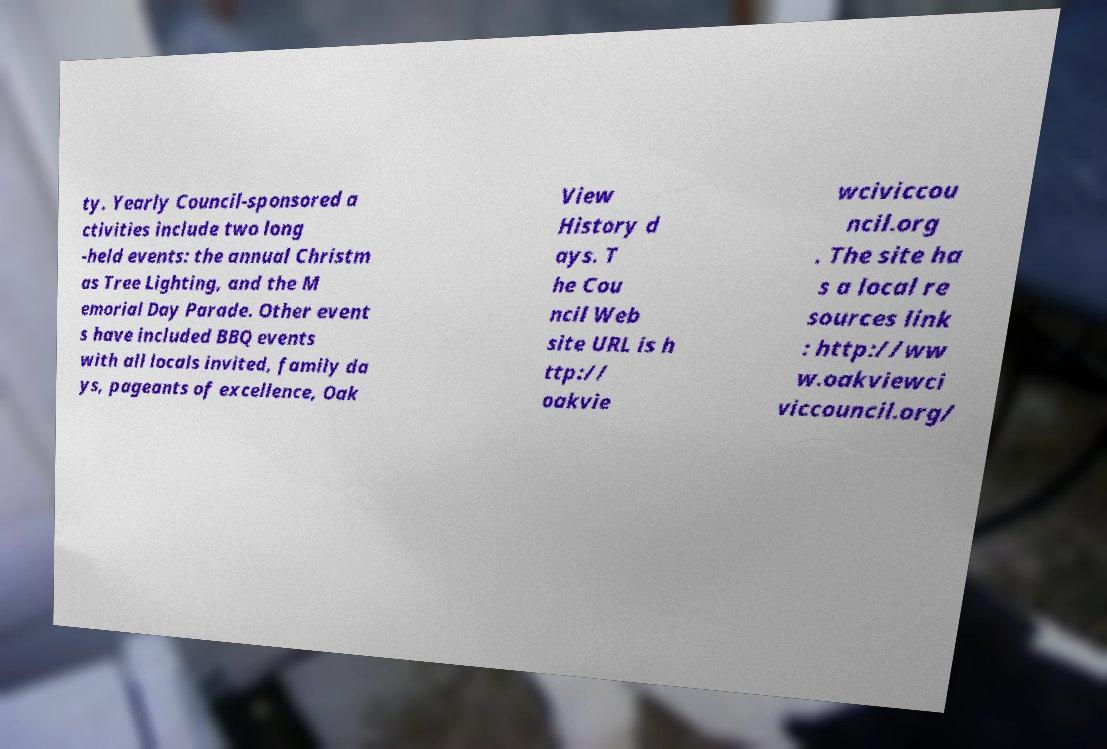Please identify and transcribe the text found in this image. ty. Yearly Council-sponsored a ctivities include two long -held events: the annual Christm as Tree Lighting, and the M emorial Day Parade. Other event s have included BBQ events with all locals invited, family da ys, pageants of excellence, Oak View History d ays. T he Cou ncil Web site URL is h ttp:// oakvie wciviccou ncil.org . The site ha s a local re sources link : http://ww w.oakviewci viccouncil.org/ 